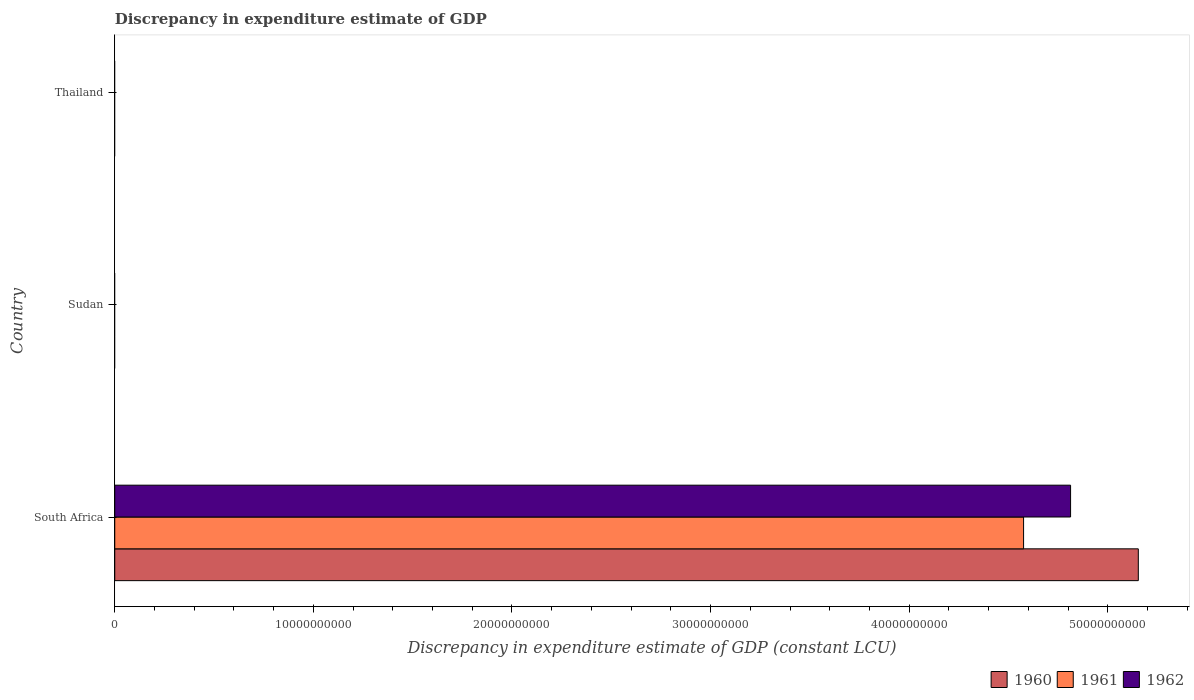Are the number of bars per tick equal to the number of legend labels?
Make the answer very short. No. What is the label of the 2nd group of bars from the top?
Provide a succinct answer. Sudan. In how many cases, is the number of bars for a given country not equal to the number of legend labels?
Offer a very short reply. 2. What is the discrepancy in expenditure estimate of GDP in 1961 in Sudan?
Provide a short and direct response. 0. Across all countries, what is the maximum discrepancy in expenditure estimate of GDP in 1960?
Offer a terse response. 5.15e+1. Across all countries, what is the minimum discrepancy in expenditure estimate of GDP in 1961?
Offer a terse response. 0. In which country was the discrepancy in expenditure estimate of GDP in 1962 maximum?
Make the answer very short. South Africa. What is the total discrepancy in expenditure estimate of GDP in 1962 in the graph?
Keep it short and to the point. 4.81e+1. What is the difference between the discrepancy in expenditure estimate of GDP in 1960 in Thailand and the discrepancy in expenditure estimate of GDP in 1962 in South Africa?
Offer a terse response. -4.81e+1. What is the average discrepancy in expenditure estimate of GDP in 1960 per country?
Your answer should be compact. 1.72e+1. What is the difference between the discrepancy in expenditure estimate of GDP in 1961 and discrepancy in expenditure estimate of GDP in 1962 in South Africa?
Make the answer very short. -2.37e+09. What is the difference between the highest and the lowest discrepancy in expenditure estimate of GDP in 1962?
Provide a short and direct response. 4.81e+1. In how many countries, is the discrepancy in expenditure estimate of GDP in 1961 greater than the average discrepancy in expenditure estimate of GDP in 1961 taken over all countries?
Keep it short and to the point. 1. Is it the case that in every country, the sum of the discrepancy in expenditure estimate of GDP in 1962 and discrepancy in expenditure estimate of GDP in 1960 is greater than the discrepancy in expenditure estimate of GDP in 1961?
Your answer should be compact. No. How many bars are there?
Your answer should be compact. 3. How many countries are there in the graph?
Ensure brevity in your answer.  3. What is the difference between two consecutive major ticks on the X-axis?
Provide a short and direct response. 1.00e+1. Are the values on the major ticks of X-axis written in scientific E-notation?
Offer a very short reply. No. Where does the legend appear in the graph?
Your response must be concise. Bottom right. What is the title of the graph?
Offer a very short reply. Discrepancy in expenditure estimate of GDP. Does "2001" appear as one of the legend labels in the graph?
Ensure brevity in your answer.  No. What is the label or title of the X-axis?
Keep it short and to the point. Discrepancy in expenditure estimate of GDP (constant LCU). What is the Discrepancy in expenditure estimate of GDP (constant LCU) in 1960 in South Africa?
Provide a short and direct response. 5.15e+1. What is the Discrepancy in expenditure estimate of GDP (constant LCU) of 1961 in South Africa?
Your response must be concise. 4.58e+1. What is the Discrepancy in expenditure estimate of GDP (constant LCU) of 1962 in South Africa?
Keep it short and to the point. 4.81e+1. What is the Discrepancy in expenditure estimate of GDP (constant LCU) in 1960 in Sudan?
Offer a terse response. 0. What is the Discrepancy in expenditure estimate of GDP (constant LCU) of 1961 in Sudan?
Make the answer very short. 0. What is the Discrepancy in expenditure estimate of GDP (constant LCU) in 1962 in Sudan?
Keep it short and to the point. 0. What is the Discrepancy in expenditure estimate of GDP (constant LCU) of 1960 in Thailand?
Provide a short and direct response. 0. What is the Discrepancy in expenditure estimate of GDP (constant LCU) in 1962 in Thailand?
Ensure brevity in your answer.  0. Across all countries, what is the maximum Discrepancy in expenditure estimate of GDP (constant LCU) of 1960?
Keep it short and to the point. 5.15e+1. Across all countries, what is the maximum Discrepancy in expenditure estimate of GDP (constant LCU) of 1961?
Offer a terse response. 4.58e+1. Across all countries, what is the maximum Discrepancy in expenditure estimate of GDP (constant LCU) of 1962?
Your answer should be very brief. 4.81e+1. Across all countries, what is the minimum Discrepancy in expenditure estimate of GDP (constant LCU) in 1960?
Your answer should be very brief. 0. Across all countries, what is the minimum Discrepancy in expenditure estimate of GDP (constant LCU) of 1962?
Provide a succinct answer. 0. What is the total Discrepancy in expenditure estimate of GDP (constant LCU) of 1960 in the graph?
Offer a terse response. 5.15e+1. What is the total Discrepancy in expenditure estimate of GDP (constant LCU) of 1961 in the graph?
Make the answer very short. 4.58e+1. What is the total Discrepancy in expenditure estimate of GDP (constant LCU) in 1962 in the graph?
Your answer should be compact. 4.81e+1. What is the average Discrepancy in expenditure estimate of GDP (constant LCU) in 1960 per country?
Your answer should be compact. 1.72e+1. What is the average Discrepancy in expenditure estimate of GDP (constant LCU) of 1961 per country?
Offer a terse response. 1.53e+1. What is the average Discrepancy in expenditure estimate of GDP (constant LCU) in 1962 per country?
Ensure brevity in your answer.  1.60e+1. What is the difference between the Discrepancy in expenditure estimate of GDP (constant LCU) in 1960 and Discrepancy in expenditure estimate of GDP (constant LCU) in 1961 in South Africa?
Make the answer very short. 5.78e+09. What is the difference between the Discrepancy in expenditure estimate of GDP (constant LCU) of 1960 and Discrepancy in expenditure estimate of GDP (constant LCU) of 1962 in South Africa?
Your answer should be compact. 3.41e+09. What is the difference between the Discrepancy in expenditure estimate of GDP (constant LCU) of 1961 and Discrepancy in expenditure estimate of GDP (constant LCU) of 1962 in South Africa?
Your response must be concise. -2.37e+09. What is the difference between the highest and the lowest Discrepancy in expenditure estimate of GDP (constant LCU) of 1960?
Ensure brevity in your answer.  5.15e+1. What is the difference between the highest and the lowest Discrepancy in expenditure estimate of GDP (constant LCU) in 1961?
Offer a very short reply. 4.58e+1. What is the difference between the highest and the lowest Discrepancy in expenditure estimate of GDP (constant LCU) in 1962?
Your answer should be compact. 4.81e+1. 